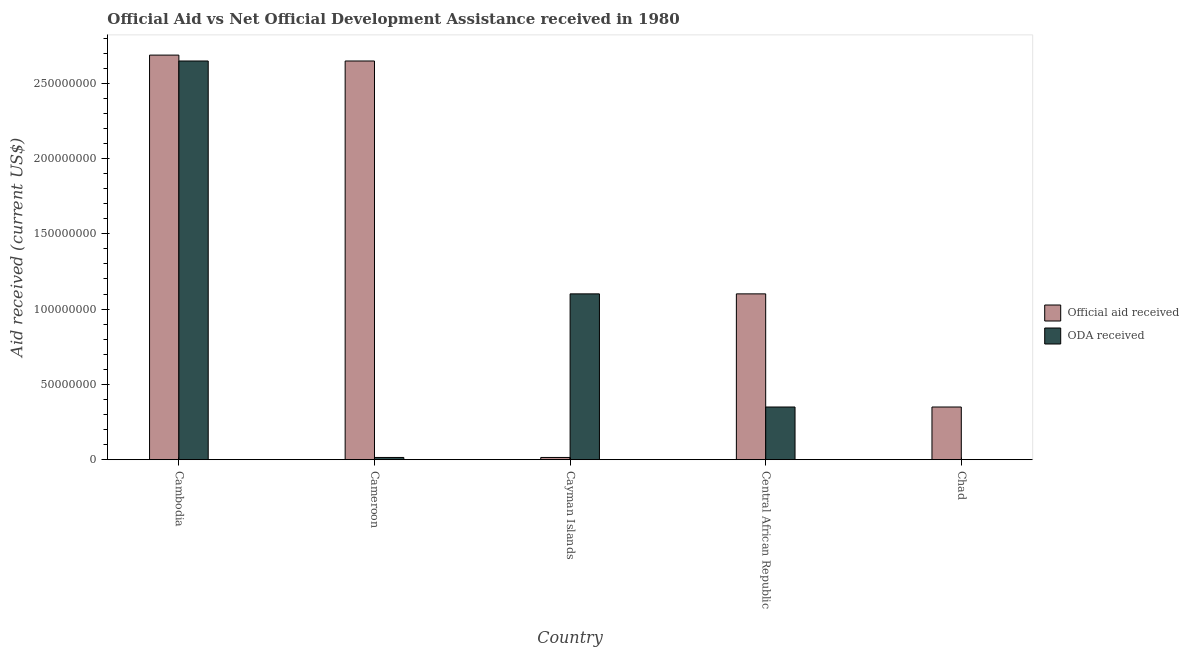Are the number of bars per tick equal to the number of legend labels?
Your answer should be very brief. No. What is the label of the 5th group of bars from the left?
Offer a terse response. Chad. In how many cases, is the number of bars for a given country not equal to the number of legend labels?
Your answer should be very brief. 1. Across all countries, what is the maximum oda received?
Your response must be concise. 2.65e+08. Across all countries, what is the minimum official aid received?
Provide a succinct answer. 1.49e+06. In which country was the official aid received maximum?
Your answer should be compact. Cambodia. What is the total oda received in the graph?
Your answer should be compact. 4.11e+08. What is the difference between the official aid received in Cambodia and that in Chad?
Ensure brevity in your answer.  2.34e+08. What is the difference between the official aid received in Cayman Islands and the oda received in Central African Republic?
Your answer should be very brief. -3.35e+07. What is the average official aid received per country?
Keep it short and to the point. 1.36e+08. What is the difference between the oda received and official aid received in Central African Republic?
Make the answer very short. -7.51e+07. In how many countries, is the oda received greater than 210000000 US$?
Your answer should be very brief. 1. What is the ratio of the oda received in Cameroon to that in Cayman Islands?
Offer a very short reply. 0.01. Is the official aid received in Cameroon less than that in Chad?
Give a very brief answer. No. What is the difference between the highest and the second highest official aid received?
Offer a very short reply. 3.91e+06. What is the difference between the highest and the lowest oda received?
Offer a terse response. 2.65e+08. In how many countries, is the official aid received greater than the average official aid received taken over all countries?
Your answer should be compact. 2. How many bars are there?
Offer a terse response. 9. Are all the bars in the graph horizontal?
Provide a short and direct response. No. How many countries are there in the graph?
Ensure brevity in your answer.  5. Does the graph contain any zero values?
Make the answer very short. Yes. Where does the legend appear in the graph?
Provide a short and direct response. Center right. How many legend labels are there?
Offer a terse response. 2. What is the title of the graph?
Your answer should be compact. Official Aid vs Net Official Development Assistance received in 1980 . Does "Urban" appear as one of the legend labels in the graph?
Offer a very short reply. No. What is the label or title of the Y-axis?
Make the answer very short. Aid received (current US$). What is the Aid received (current US$) in Official aid received in Cambodia?
Your answer should be very brief. 2.69e+08. What is the Aid received (current US$) of ODA received in Cambodia?
Provide a succinct answer. 2.65e+08. What is the Aid received (current US$) in Official aid received in Cameroon?
Give a very brief answer. 2.65e+08. What is the Aid received (current US$) of ODA received in Cameroon?
Offer a very short reply. 1.49e+06. What is the Aid received (current US$) of Official aid received in Cayman Islands?
Provide a succinct answer. 1.49e+06. What is the Aid received (current US$) of ODA received in Cayman Islands?
Make the answer very short. 1.10e+08. What is the Aid received (current US$) in Official aid received in Central African Republic?
Offer a very short reply. 1.10e+08. What is the Aid received (current US$) of ODA received in Central African Republic?
Make the answer very short. 3.50e+07. What is the Aid received (current US$) of Official aid received in Chad?
Make the answer very short. 3.50e+07. Across all countries, what is the maximum Aid received (current US$) in Official aid received?
Your response must be concise. 2.69e+08. Across all countries, what is the maximum Aid received (current US$) in ODA received?
Offer a very short reply. 2.65e+08. Across all countries, what is the minimum Aid received (current US$) in Official aid received?
Your answer should be compact. 1.49e+06. What is the total Aid received (current US$) in Official aid received in the graph?
Your answer should be compact. 6.80e+08. What is the total Aid received (current US$) of ODA received in the graph?
Provide a short and direct response. 4.11e+08. What is the difference between the Aid received (current US$) in Official aid received in Cambodia and that in Cameroon?
Ensure brevity in your answer.  3.91e+06. What is the difference between the Aid received (current US$) of ODA received in Cambodia and that in Cameroon?
Give a very brief answer. 2.63e+08. What is the difference between the Aid received (current US$) of Official aid received in Cambodia and that in Cayman Islands?
Your answer should be very brief. 2.67e+08. What is the difference between the Aid received (current US$) in ODA received in Cambodia and that in Cayman Islands?
Your response must be concise. 1.55e+08. What is the difference between the Aid received (current US$) in Official aid received in Cambodia and that in Central African Republic?
Offer a terse response. 1.59e+08. What is the difference between the Aid received (current US$) in ODA received in Cambodia and that in Central African Republic?
Your answer should be compact. 2.30e+08. What is the difference between the Aid received (current US$) of Official aid received in Cambodia and that in Chad?
Your answer should be very brief. 2.34e+08. What is the difference between the Aid received (current US$) in Official aid received in Cameroon and that in Cayman Islands?
Your response must be concise. 2.63e+08. What is the difference between the Aid received (current US$) in ODA received in Cameroon and that in Cayman Islands?
Your answer should be very brief. -1.09e+08. What is the difference between the Aid received (current US$) in Official aid received in Cameroon and that in Central African Republic?
Provide a short and direct response. 1.55e+08. What is the difference between the Aid received (current US$) in ODA received in Cameroon and that in Central African Republic?
Provide a succinct answer. -3.35e+07. What is the difference between the Aid received (current US$) of Official aid received in Cameroon and that in Chad?
Provide a short and direct response. 2.30e+08. What is the difference between the Aid received (current US$) in Official aid received in Cayman Islands and that in Central African Republic?
Your answer should be compact. -1.09e+08. What is the difference between the Aid received (current US$) of ODA received in Cayman Islands and that in Central African Republic?
Give a very brief answer. 7.51e+07. What is the difference between the Aid received (current US$) in Official aid received in Cayman Islands and that in Chad?
Keep it short and to the point. -3.35e+07. What is the difference between the Aid received (current US$) of Official aid received in Central African Republic and that in Chad?
Provide a short and direct response. 7.51e+07. What is the difference between the Aid received (current US$) of Official aid received in Cambodia and the Aid received (current US$) of ODA received in Cameroon?
Make the answer very short. 2.67e+08. What is the difference between the Aid received (current US$) of Official aid received in Cambodia and the Aid received (current US$) of ODA received in Cayman Islands?
Provide a short and direct response. 1.59e+08. What is the difference between the Aid received (current US$) in Official aid received in Cambodia and the Aid received (current US$) in ODA received in Central African Republic?
Offer a terse response. 2.34e+08. What is the difference between the Aid received (current US$) in Official aid received in Cameroon and the Aid received (current US$) in ODA received in Cayman Islands?
Your answer should be compact. 1.55e+08. What is the difference between the Aid received (current US$) of Official aid received in Cameroon and the Aid received (current US$) of ODA received in Central African Republic?
Your answer should be compact. 2.30e+08. What is the difference between the Aid received (current US$) in Official aid received in Cayman Islands and the Aid received (current US$) in ODA received in Central African Republic?
Offer a terse response. -3.35e+07. What is the average Aid received (current US$) of Official aid received per country?
Provide a succinct answer. 1.36e+08. What is the average Aid received (current US$) in ODA received per country?
Give a very brief answer. 8.23e+07. What is the difference between the Aid received (current US$) in Official aid received and Aid received (current US$) in ODA received in Cambodia?
Ensure brevity in your answer.  3.91e+06. What is the difference between the Aid received (current US$) in Official aid received and Aid received (current US$) in ODA received in Cameroon?
Your answer should be very brief. 2.63e+08. What is the difference between the Aid received (current US$) in Official aid received and Aid received (current US$) in ODA received in Cayman Islands?
Ensure brevity in your answer.  -1.09e+08. What is the difference between the Aid received (current US$) in Official aid received and Aid received (current US$) in ODA received in Central African Republic?
Your answer should be very brief. 7.51e+07. What is the ratio of the Aid received (current US$) in Official aid received in Cambodia to that in Cameroon?
Your response must be concise. 1.01. What is the ratio of the Aid received (current US$) in ODA received in Cambodia to that in Cameroon?
Offer a very short reply. 177.69. What is the ratio of the Aid received (current US$) of Official aid received in Cambodia to that in Cayman Islands?
Your answer should be compact. 180.32. What is the ratio of the Aid received (current US$) in ODA received in Cambodia to that in Cayman Islands?
Provide a succinct answer. 2.4. What is the ratio of the Aid received (current US$) of Official aid received in Cambodia to that in Central African Republic?
Your answer should be compact. 2.44. What is the ratio of the Aid received (current US$) in ODA received in Cambodia to that in Central African Republic?
Your response must be concise. 7.57. What is the ratio of the Aid received (current US$) of Official aid received in Cambodia to that in Chad?
Ensure brevity in your answer.  7.68. What is the ratio of the Aid received (current US$) of Official aid received in Cameroon to that in Cayman Islands?
Provide a short and direct response. 177.69. What is the ratio of the Aid received (current US$) of ODA received in Cameroon to that in Cayman Islands?
Offer a terse response. 0.01. What is the ratio of the Aid received (current US$) of Official aid received in Cameroon to that in Central African Republic?
Ensure brevity in your answer.  2.4. What is the ratio of the Aid received (current US$) of ODA received in Cameroon to that in Central African Republic?
Make the answer very short. 0.04. What is the ratio of the Aid received (current US$) in Official aid received in Cameroon to that in Chad?
Provide a short and direct response. 7.57. What is the ratio of the Aid received (current US$) of Official aid received in Cayman Islands to that in Central African Republic?
Offer a terse response. 0.01. What is the ratio of the Aid received (current US$) in ODA received in Cayman Islands to that in Central African Republic?
Offer a terse response. 3.15. What is the ratio of the Aid received (current US$) in Official aid received in Cayman Islands to that in Chad?
Provide a short and direct response. 0.04. What is the ratio of the Aid received (current US$) of Official aid received in Central African Republic to that in Chad?
Give a very brief answer. 3.15. What is the difference between the highest and the second highest Aid received (current US$) of Official aid received?
Provide a succinct answer. 3.91e+06. What is the difference between the highest and the second highest Aid received (current US$) in ODA received?
Ensure brevity in your answer.  1.55e+08. What is the difference between the highest and the lowest Aid received (current US$) in Official aid received?
Your response must be concise. 2.67e+08. What is the difference between the highest and the lowest Aid received (current US$) in ODA received?
Your answer should be very brief. 2.65e+08. 